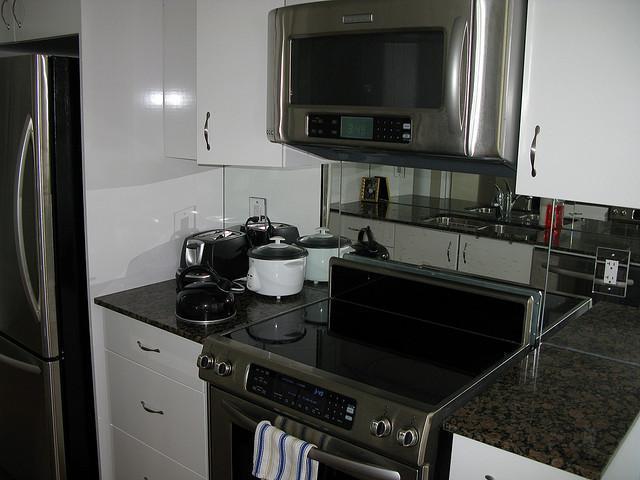What is the white cooker called?
Answer the question by selecting the correct answer among the 4 following choices and explain your choice with a short sentence. The answer should be formatted with the following format: `Answer: choice
Rationale: rationale.`
Options: Rice cooker, dutch oven, air fryer, ninja. Answer: rice cooker.
Rationale: The small bowl with a lid is called the rice cooker. 